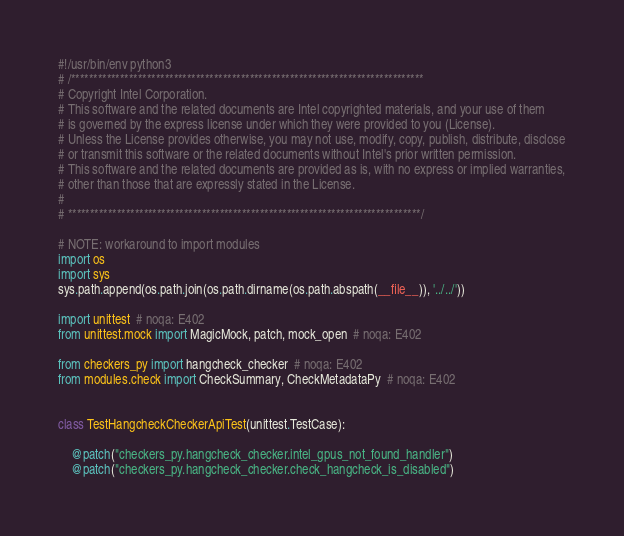Convert code to text. <code><loc_0><loc_0><loc_500><loc_500><_Python_>#!/usr/bin/env python3
# /*******************************************************************************
# Copyright Intel Corporation.
# This software and the related documents are Intel copyrighted materials, and your use of them
# is governed by the express license under which they were provided to you (License).
# Unless the License provides otherwise, you may not use, modify, copy, publish, distribute, disclose
# or transmit this software or the related documents without Intel's prior written permission.
# This software and the related documents are provided as is, with no express or implied warranties,
# other than those that are expressly stated in the License.
#
# *******************************************************************************/

# NOTE: workaround to import modules
import os
import sys
sys.path.append(os.path.join(os.path.dirname(os.path.abspath(__file__)), '../../'))

import unittest  # noqa: E402
from unittest.mock import MagicMock, patch, mock_open  # noqa: E402

from checkers_py import hangcheck_checker  # noqa: E402
from modules.check import CheckSummary, CheckMetadataPy  # noqa: E402


class TestHangcheckCheckerApiTest(unittest.TestCase):

    @patch("checkers_py.hangcheck_checker.intel_gpus_not_found_handler")
    @patch("checkers_py.hangcheck_checker.check_hangcheck_is_disabled")</code> 